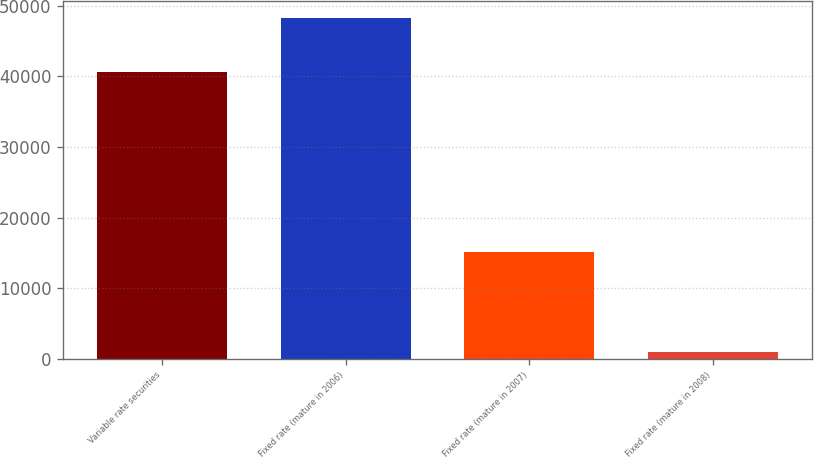<chart> <loc_0><loc_0><loc_500><loc_500><bar_chart><fcel>Variable rate securities<fcel>Fixed rate (mature in 2006)<fcel>Fixed rate (mature in 2007)<fcel>Fixed rate (mature in 2008)<nl><fcel>40650<fcel>48282<fcel>15085<fcel>1000<nl></chart> 